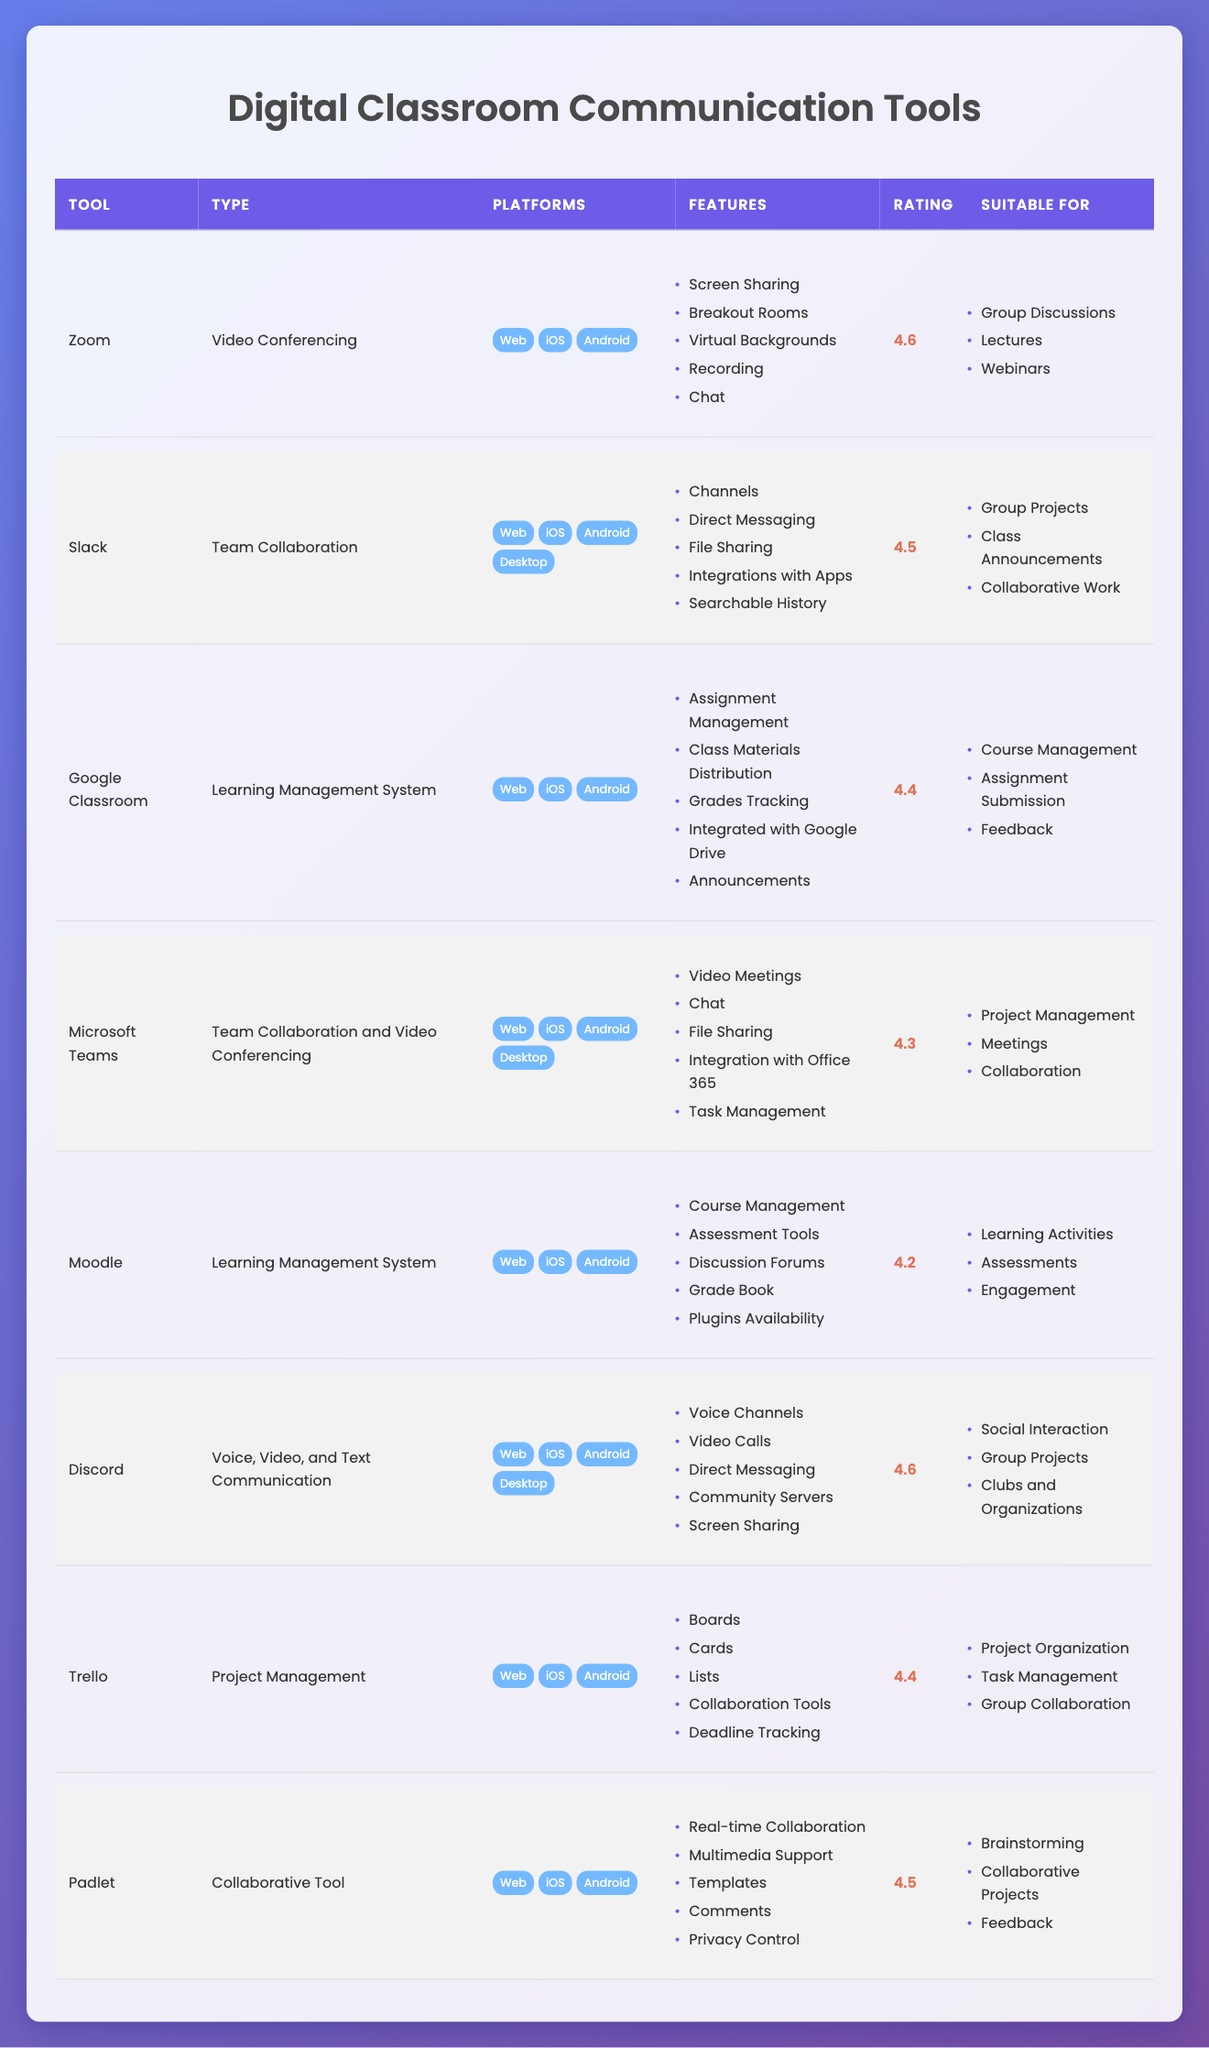What is the highest user rating among the communication tools? The highest user rating in the table is 4.6, which is shared by both Zoom and Discord.
Answer: 4.6 Which tool is suitable for both group discussions and webinars? Zoom is noted as suitable for both group discussions and webinars, which you can see listed under its "Suitable For" column.
Answer: Zoom Does Padlet have real-time collaboration features? Yes, Padlet includes real-time collaboration features as specified in its "Features" section in the table.
Answer: Yes How many tools are categorized specifically as Learning Management Systems? There are two tools categorized as Learning Management Systems: Google Classroom and Moodle.
Answer: 2 Which team collaboration tool has the lowest user rating? Microsoft Teams has the lowest user rating among the team collaboration tools at 4.3, compared to Slack which has a rating of 4.5.
Answer: Microsoft Teams What features do both Slack and Discord share? Both Slack and Discord have features such as file sharing and direct messaging, which can be found in their respective "Features" columns in the table.
Answer: File sharing and direct messaging Which communication tool supports the most platforms? Slack and Discord support the most platforms (Web, iOS, Android, and Desktop), whereas other tools like Zoom and Google Classroom support fewer platforms.
Answer: Slack and Discord What is the average user rating of all listed tools? To calculate the average rating, sum all the user ratings (4.6 + 4.5 + 4.4 + 4.3 + 4.2 + 4.6 + 4.4 + 4.5) = 35.5. There are 8 tools, so the average rating is 35.5 / 8 = 4.4375.
Answer: 4.44 Is Google Classroom suitable for class announcements? No, Google Classroom is specifically listed for course management, assignment submission, and feedback, but not for class announcements.
Answer: No 